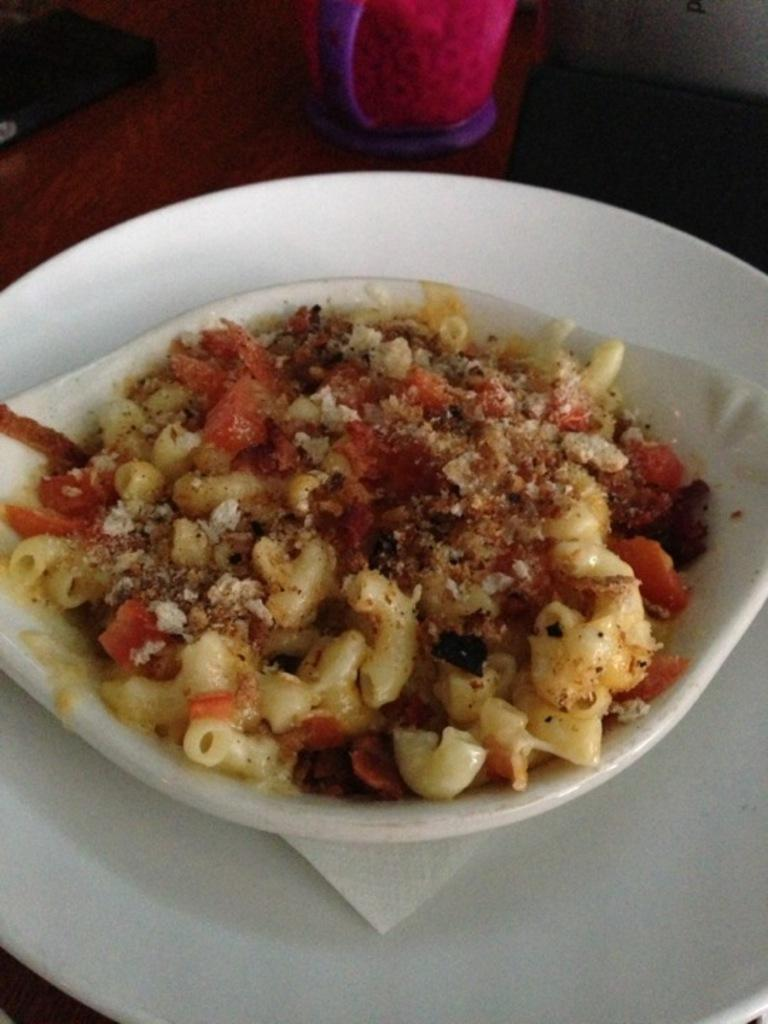What type of food items can be seen in the image? There are food items in a bowl in the image. What is located at the bottom of the image? There is a white color plate at the bottom of the image. What other type of dish is present in the image? There is a cup in the image. What year is depicted on the cup in the image? There is no year depicted on the cup in the image. What type of nut is present in the image? There is no nut present in the image. 